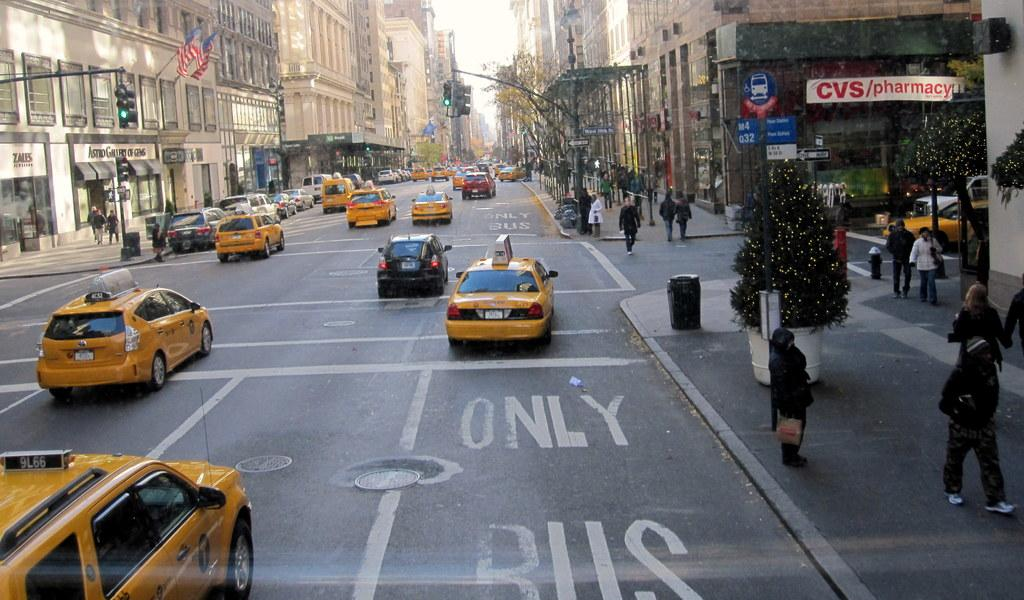Provide a one-sentence caption for the provided image. The bus stop by CVS is handicap accessible and seating only. 